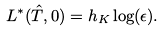Convert formula to latex. <formula><loc_0><loc_0><loc_500><loc_500>L ^ { * } ( \hat { T } , 0 ) = h _ { K } \log ( \epsilon ) .</formula> 